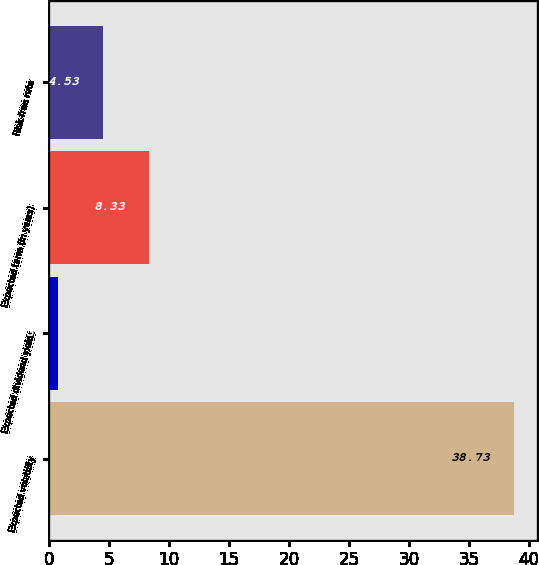<chart> <loc_0><loc_0><loc_500><loc_500><bar_chart><fcel>Expected volatility<fcel>Expected dividend yields<fcel>Expected term (in years)<fcel>Risk-free rate<nl><fcel>38.73<fcel>0.73<fcel>8.33<fcel>4.53<nl></chart> 